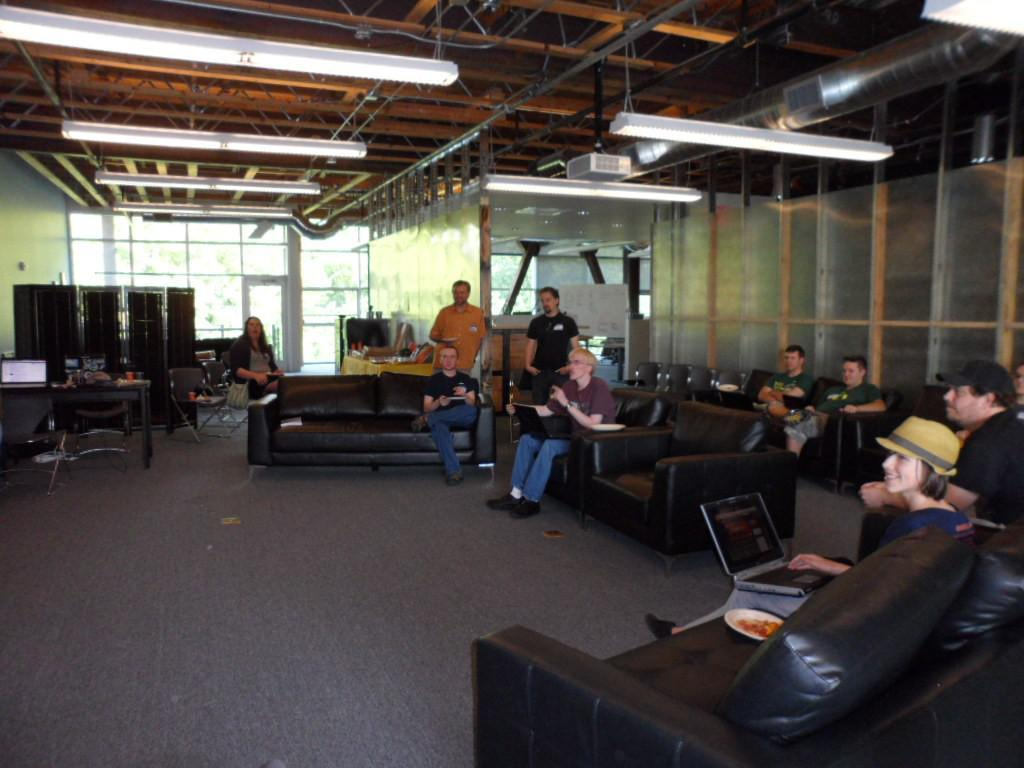Who or what can be seen in the image? There are people in the image. What type of furniture is present in the image? There are sofas in the image. What object might be used for serving food? There is a plate in the image. What electronic device is visible in the image? There is a laptop in the image. What can provide illumination in the image? There are lights in the image. What color is the rose on the coat of the father in the image? There is no rose or father present in the image. 